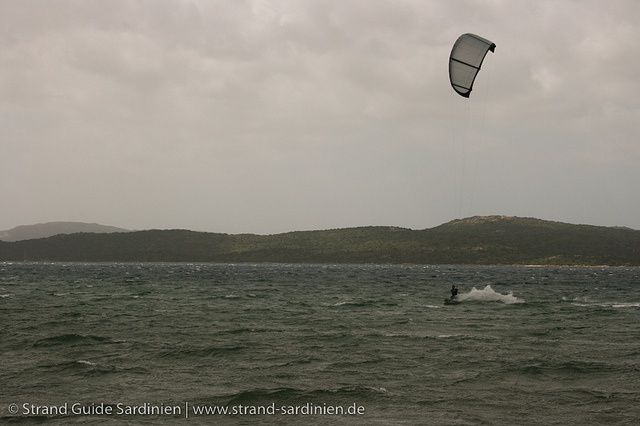Describe the objects in this image and their specific colors. I can see kite in darkgray, gray, and black tones, people in darkgray, black, and gray tones, and surfboard in darkgray, black, and gray tones in this image. 